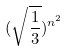<formula> <loc_0><loc_0><loc_500><loc_500>( \sqrt { \frac { 1 } { 3 } } ) ^ { n ^ { 2 } }</formula> 